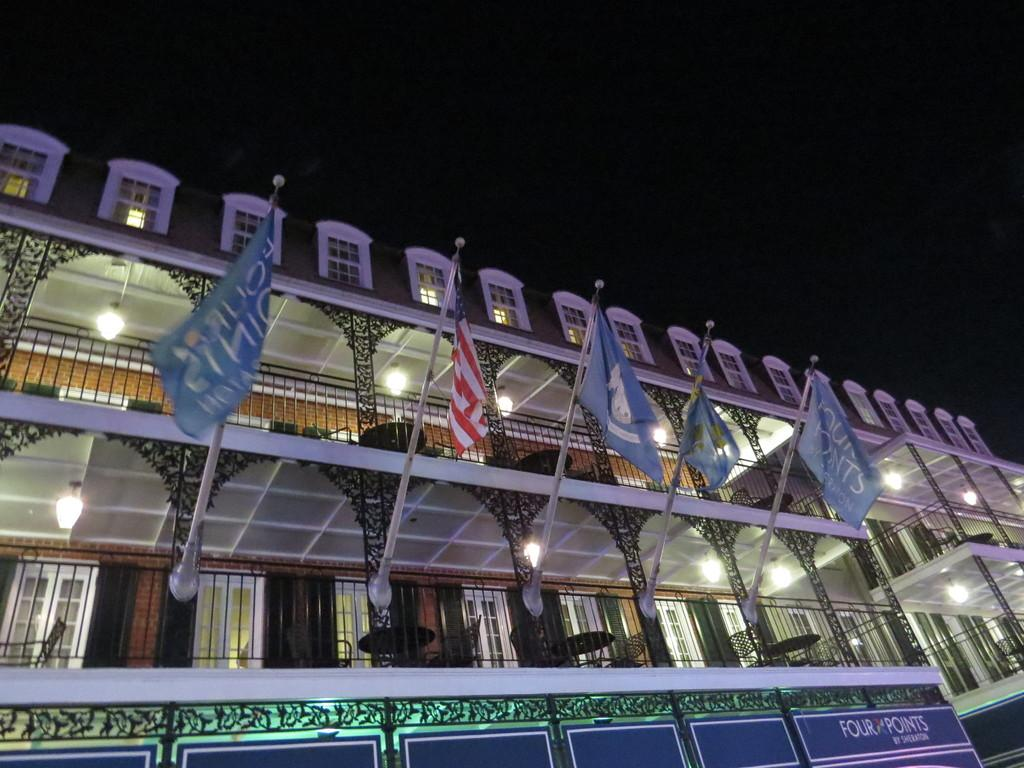What type of structure is visible in the image? There is a building in the image. Are there any distinguishing features associated with the building? Yes, there are flags associated with the building. What can be found inside the building? Inside the building, there are tables, chairs, and lights. What type of picture is hanging on the wall inside the building? There is no information about a picture hanging on the wall inside the building, so we cannot answer that question. 